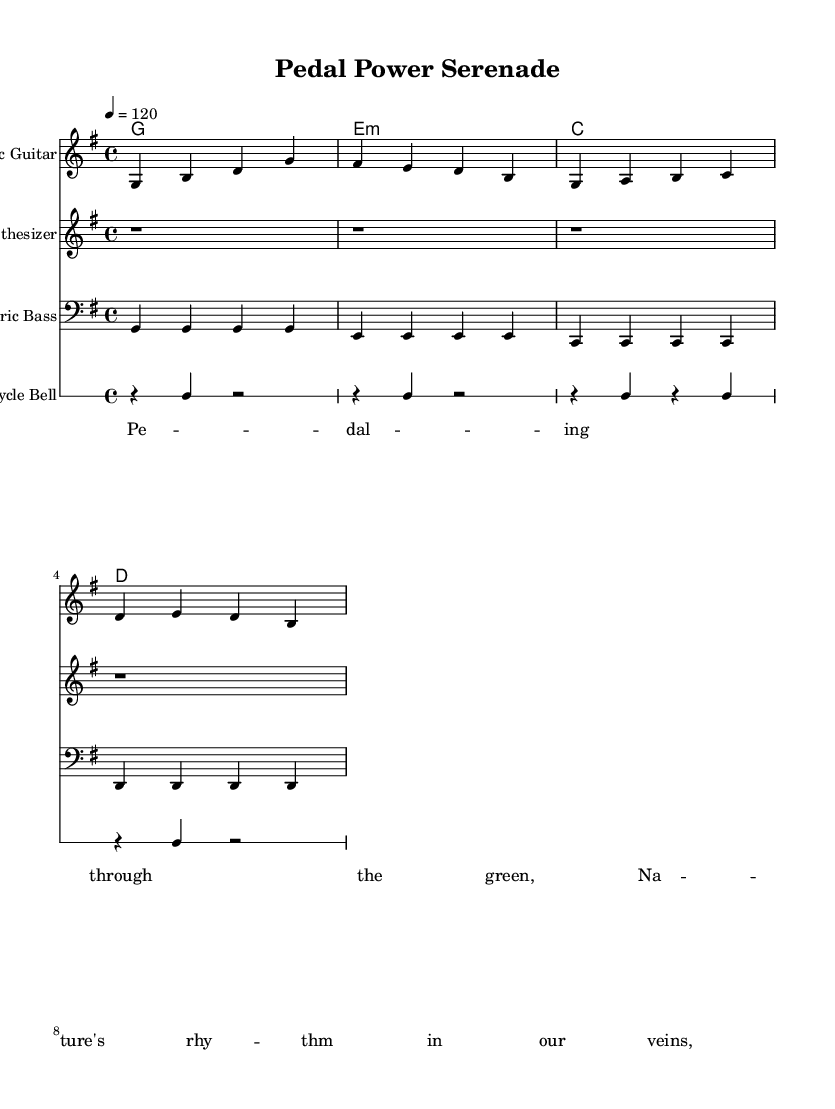What is the key signature of this music? The key signature indicated in the music is G major, which has one sharp (F#). This conclusion is drawn by looking at the key signature marking placed at the beginning of the staff.
Answer: G major What is the time signature of this music? The time signature displayed at the beginning of the score is 4/4. This can be identified by the notation found next to the key signature, showing the meter of the piece.
Answer: 4/4 What is the tempo marking for this composition? The tempo marking indicates a speed of 120 beats per minute, as stated above the staff in the score. This tempo determines how fast the piece should be played.
Answer: 120 What instruments are featured in this piece? The instruments indicated in the score are Acoustic Guitar, Synthesizer, Electric Bass, and Bicycle Bell. Each instrument is listed clearly at the beginning of its respective staff.
Answer: Acoustic Guitar, Synthesizer, Electric Bass, Bicycle Bell What chord progressions are used in this score? The chord progression is G, E minor, C, D. These chords are denoted in the ChordNames section of the score, providing a harmonic foundation for the piece.
Answer: G, E minor, C, D What is the main theme expressed in the lyrics? The lyrics reflect themes of connection with nature and the experience of cycling, indicated by phrases like "Pedaling through the green" and "Nature's rhythm in our veins." These phrases summarize the central idea of the song.
Answer: Connection with nature 